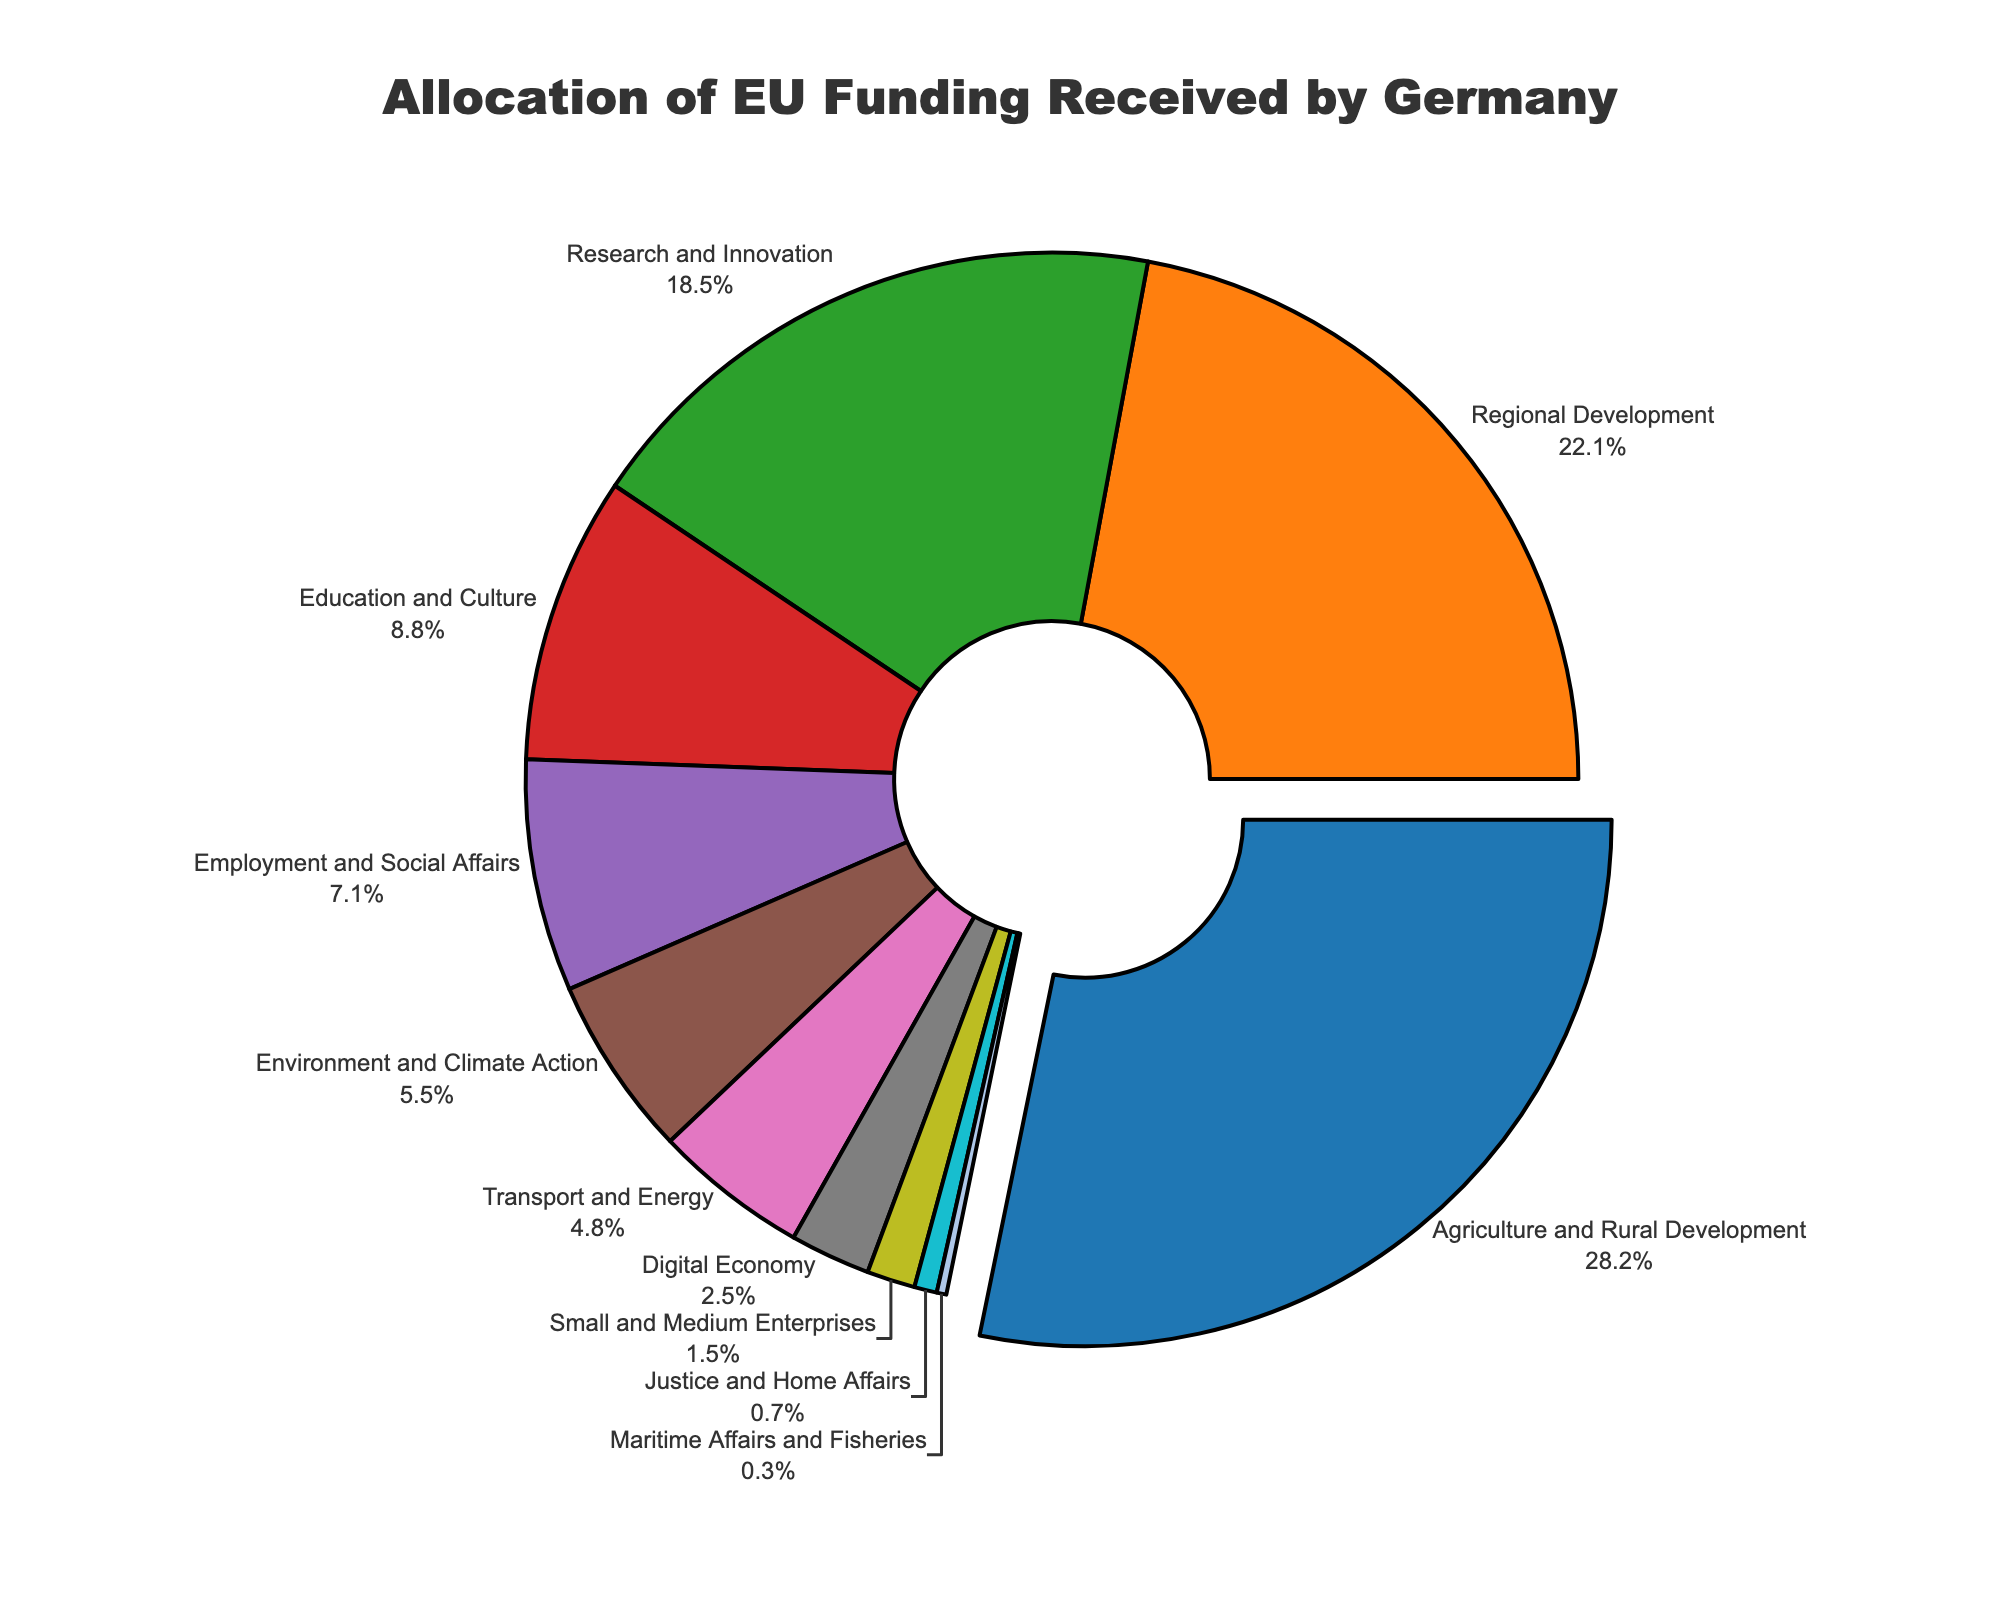what percentage of EU funding is allocated to Agriculture and Rural Development? The slice for Agriculture and Rural Development indicates 28.5% of the total funding, which is clearly labeled.
Answer: 28.5% Which sector receives the second-highest allocation of EU funding? By examining the pie chart, the sector with the second-largest slice is Regional Development, labeled with 22.3%.
Answer: Regional Development What is the cumulative percentage allocation for Education and Culture, Digital Economy, and Justice and Home Affairs? Summing the percentages: Education and Culture (8.9%) + Digital Economy (2.5%) + Justice and Home Affairs (0.7%) = 8.9 + 2.5 + 0.7
Answer: 12.1% How much more EU funding does Agriculture and Rural Development receive compared to Research and Innovation? The difference in their allocations is 28.5% for Agriculture and Rural Development minus 18.7% for Research and Innovation. 28.5 - 18.7
Answer: 9.8% What is the smallest sector by EU funding allocation, and what is its percentage? The smallest sector, as indicated by the smallest slice, is Maritime Affairs and Fisheries at 0.3%.
Answer: Maritime Affairs and Fisheries, 0.3% Which sector falls just between Research and Innovation and Education and Culture in terms of funding allocation? The slice between Research and Innovation (18.7%) and Education and Culture (8.9%) is for Employment and Social Affairs, labeled with 7.2%.
Answer: Employment and Social Affairs If the allocation for Small and Medium Enterprises was doubled, what would its new percentage be? Doubling the percentage for Small and Medium Enterprises: 1.5% * 2 = 3%
Answer: 3% Comparing Digital Economy and Environment and Climate Action, which sector gets more funding and by how much? Environment and Climate Action receives 5.6%, whereas Digital Economy gets 2.5%. The difference is 5.6% - 2.5%.
Answer: Environment and Climate Action by 3.1% What is the combined percentage of allocations for sectors that receive less than 10% funding each? Adding percentages for sectors under 10%: Education and Culture (8.9%) + Employment and Social Affairs (7.2%) + Environment and Climate Action (5.6%) + Transport and Energy (4.8%) + Digital Economy (2.5%) + Small and Medium Enterprises (1.5%) + Justice and Home Affairs (0.7%) + Maritime Affairs and Fisheries (0.3%) = 31.5
Answer: 31.5% What is the average percentage allocation across all sectors? Summing all sector percentages: 28.5 + 22.3 + 18.7 + 8.9 + 7.2 + 5.6 + 4.8 + 2.5 + 1.5 + 0.7 + 0.3 = 100. Dividing by the number of sectors (11) gives: 100 / 11
Answer: 9.1% 